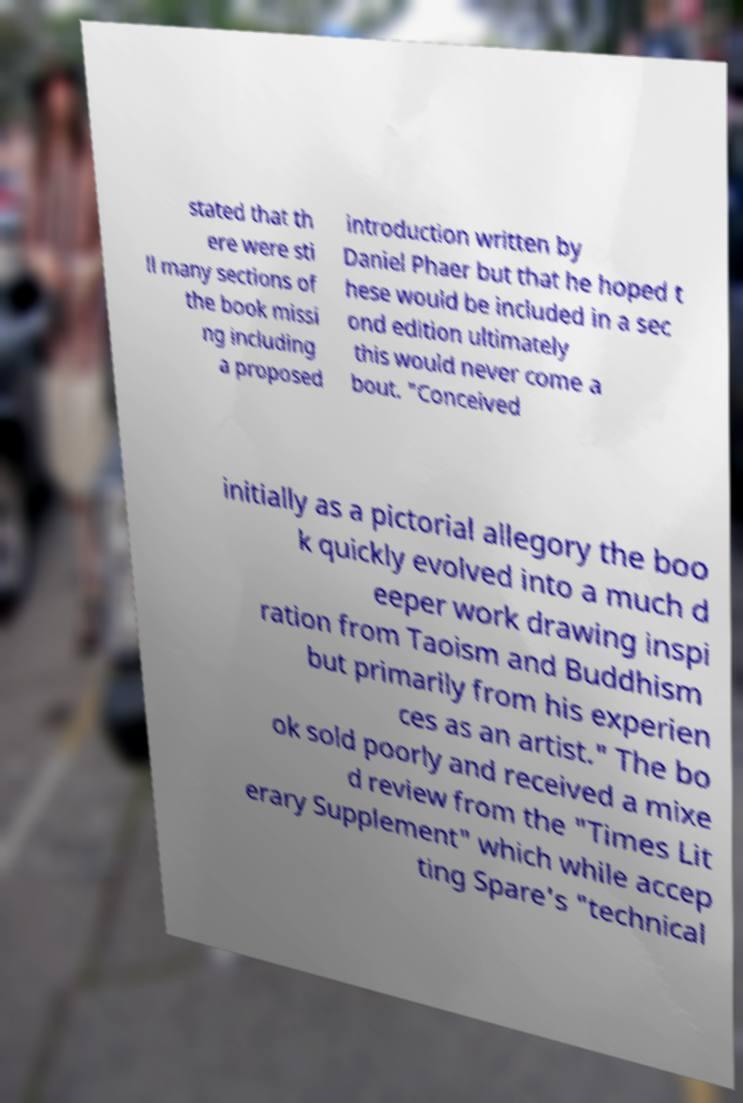Can you read and provide the text displayed in the image?This photo seems to have some interesting text. Can you extract and type it out for me? stated that th ere were sti ll many sections of the book missi ng including a proposed introduction written by Daniel Phaer but that he hoped t hese would be included in a sec ond edition ultimately this would never come a bout. "Conceived initially as a pictorial allegory the boo k quickly evolved into a much d eeper work drawing inspi ration from Taoism and Buddhism but primarily from his experien ces as an artist." The bo ok sold poorly and received a mixe d review from the "Times Lit erary Supplement" which while accep ting Spare's "technical 